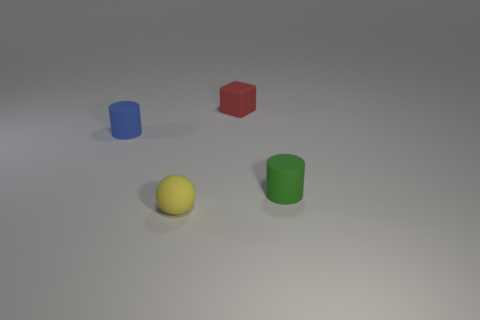Can you tell me which objects are casting shadows and describe their orientation? Each object in the image is casting a shadow due to the light source. The shadows stretch towards the bottom right of the image, indicating that the light is coming from the top left. The shadows are proportional to the size and shape of each object, with distinctive outlines that match the blue cylinder, red cube, yellow sphere, and green cylinder. 